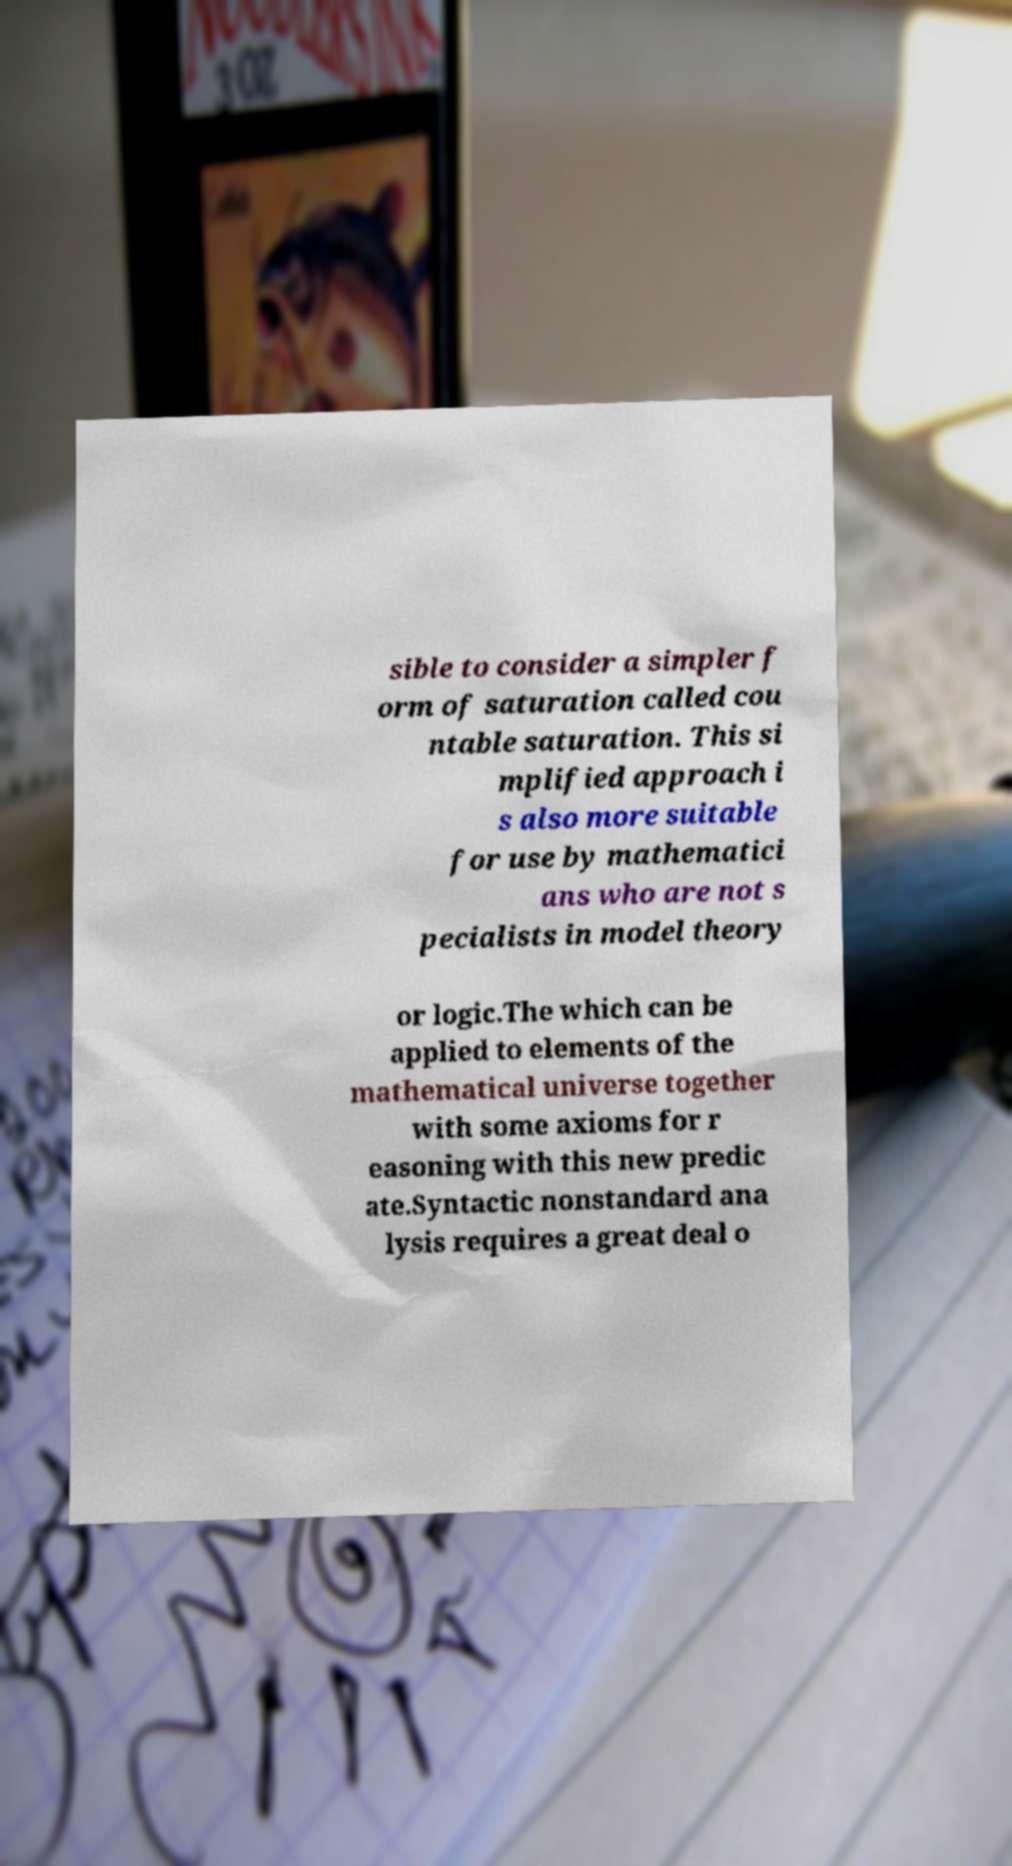Please read and relay the text visible in this image. What does it say? sible to consider a simpler f orm of saturation called cou ntable saturation. This si mplified approach i s also more suitable for use by mathematici ans who are not s pecialists in model theory or logic.The which can be applied to elements of the mathematical universe together with some axioms for r easoning with this new predic ate.Syntactic nonstandard ana lysis requires a great deal o 